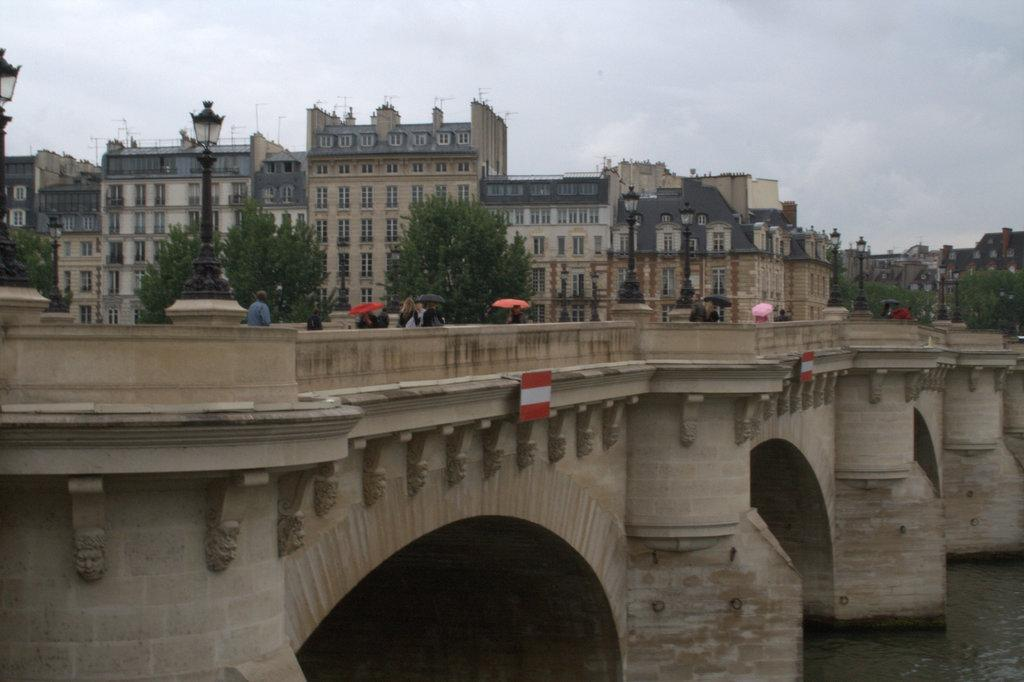What is happening in the foreground of the picture? There are people on the bridge in the foreground of the picture. What can be seen below the bridge? Water is visible in the foreground of the picture. What is located in the center of the picture? There are trees, street lights, and buildings in the center of the picture. How would you describe the sky in the picture? The sky is cloudy in the picture. What scientific discovery is being discussed by the people on the bridge? There is no indication in the image that the people on the bridge are discussing any scientific discoveries. What type of air is present in the picture? The image does not provide information about the type of air present; it only shows the sky, which is cloudy. 